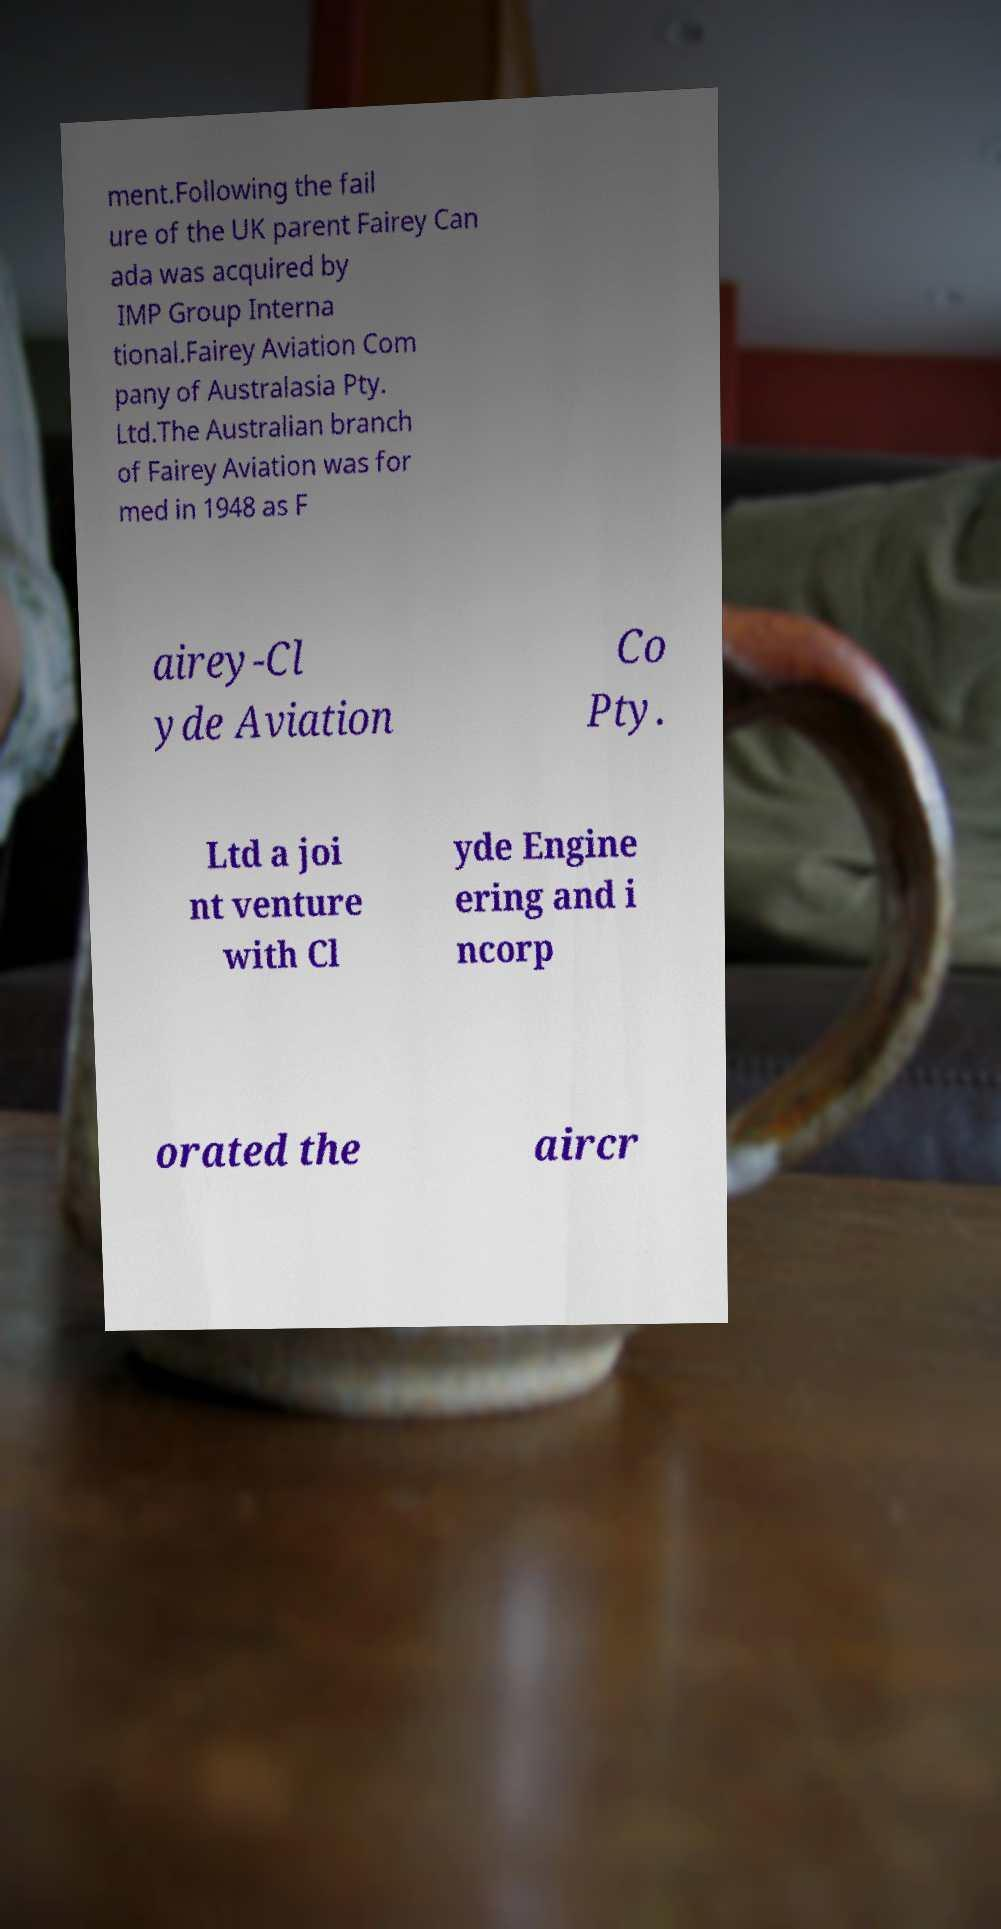What messages or text are displayed in this image? I need them in a readable, typed format. ment.Following the fail ure of the UK parent Fairey Can ada was acquired by IMP Group Interna tional.Fairey Aviation Com pany of Australasia Pty. Ltd.The Australian branch of Fairey Aviation was for med in 1948 as F airey-Cl yde Aviation Co Pty. Ltd a joi nt venture with Cl yde Engine ering and i ncorp orated the aircr 